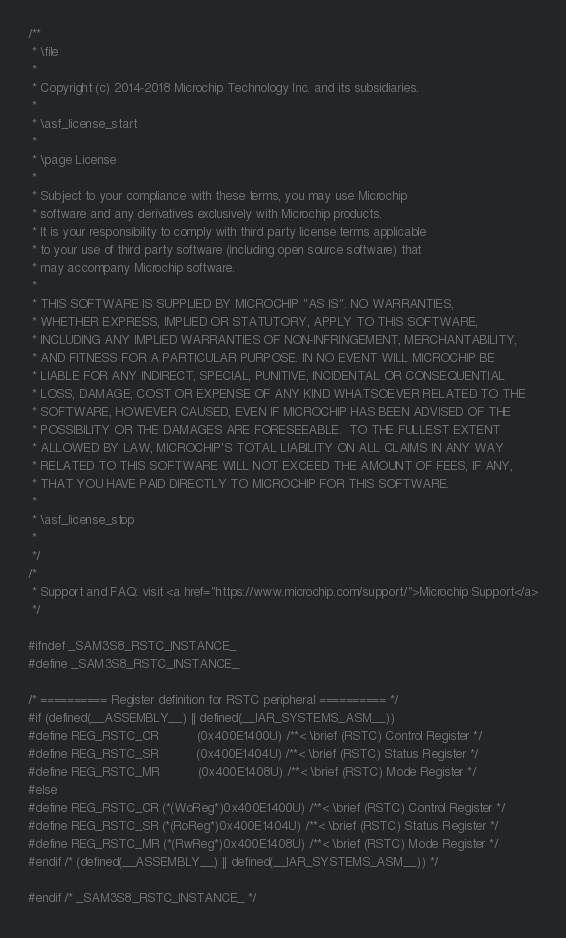Convert code to text. <code><loc_0><loc_0><loc_500><loc_500><_C_>/**
 * \file
 *
 * Copyright (c) 2014-2018 Microchip Technology Inc. and its subsidiaries.
 *
 * \asf_license_start
 *
 * \page License
 *
 * Subject to your compliance with these terms, you may use Microchip
 * software and any derivatives exclusively with Microchip products.
 * It is your responsibility to comply with third party license terms applicable
 * to your use of third party software (including open source software) that
 * may accompany Microchip software.
 *
 * THIS SOFTWARE IS SUPPLIED BY MICROCHIP "AS IS". NO WARRANTIES,
 * WHETHER EXPRESS, IMPLIED OR STATUTORY, APPLY TO THIS SOFTWARE,
 * INCLUDING ANY IMPLIED WARRANTIES OF NON-INFRINGEMENT, MERCHANTABILITY,
 * AND FITNESS FOR A PARTICULAR PURPOSE. IN NO EVENT WILL MICROCHIP BE
 * LIABLE FOR ANY INDIRECT, SPECIAL, PUNITIVE, INCIDENTAL OR CONSEQUENTIAL
 * LOSS, DAMAGE, COST OR EXPENSE OF ANY KIND WHATSOEVER RELATED TO THE
 * SOFTWARE, HOWEVER CAUSED, EVEN IF MICROCHIP HAS BEEN ADVISED OF THE
 * POSSIBILITY OR THE DAMAGES ARE FORESEEABLE.  TO THE FULLEST EXTENT
 * ALLOWED BY LAW, MICROCHIP'S TOTAL LIABILITY ON ALL CLAIMS IN ANY WAY
 * RELATED TO THIS SOFTWARE WILL NOT EXCEED THE AMOUNT OF FEES, IF ANY,
 * THAT YOU HAVE PAID DIRECTLY TO MICROCHIP FOR THIS SOFTWARE.
 *
 * \asf_license_stop
 *
 */
/*
 * Support and FAQ: visit <a href="https://www.microchip.com/support/">Microchip Support</a>
 */

#ifndef _SAM3S8_RSTC_INSTANCE_
#define _SAM3S8_RSTC_INSTANCE_

/* ========== Register definition for RSTC peripheral ========== */
#if (defined(__ASSEMBLY__) || defined(__IAR_SYSTEMS_ASM__))
#define REG_RSTC_CR          (0x400E1400U) /**< \brief (RSTC) Control Register */
#define REG_RSTC_SR          (0x400E1404U) /**< \brief (RSTC) Status Register */
#define REG_RSTC_MR          (0x400E1408U) /**< \brief (RSTC) Mode Register */
#else
#define REG_RSTC_CR (*(WoReg*)0x400E1400U) /**< \brief (RSTC) Control Register */
#define REG_RSTC_SR (*(RoReg*)0x400E1404U) /**< \brief (RSTC) Status Register */
#define REG_RSTC_MR (*(RwReg*)0x400E1408U) /**< \brief (RSTC) Mode Register */
#endif /* (defined(__ASSEMBLY__) || defined(__IAR_SYSTEMS_ASM__)) */

#endif /* _SAM3S8_RSTC_INSTANCE_ */
</code> 